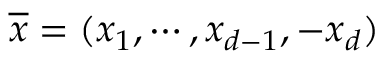Convert formula to latex. <formula><loc_0><loc_0><loc_500><loc_500>\overline { x } = ( x _ { 1 } , \cdots , x _ { d - 1 } , - x _ { d } )</formula> 